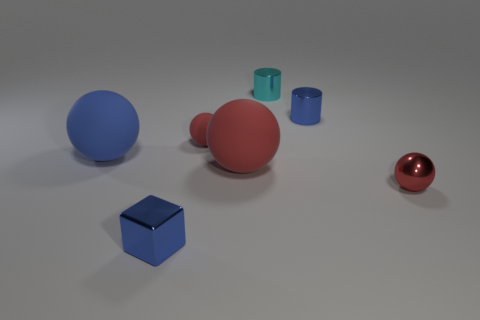There is a tiny ball that is on the right side of the big red rubber ball; is its color the same as the tiny rubber thing?
Offer a terse response. Yes. There is a blue matte object that is the same shape as the small red shiny thing; what size is it?
Offer a terse response. Large. What number of small spheres have the same material as the cube?
Ensure brevity in your answer.  1. There is a small blue thing behind the big object that is left of the small blue cube; is there a blue metallic thing on the left side of it?
Provide a short and direct response. Yes. What is the shape of the small rubber object?
Make the answer very short. Sphere. Is the tiny red sphere that is left of the tiny red shiny thing made of the same material as the blue thing on the right side of the small blue metallic block?
Keep it short and to the point. No. How many tiny shiny cylinders are the same color as the small block?
Provide a short and direct response. 1. There is a small metal thing that is in front of the tiny blue cylinder and left of the tiny red metal sphere; what is its shape?
Provide a short and direct response. Cube. There is a rubber thing that is both left of the large red rubber ball and on the right side of the large blue rubber thing; what color is it?
Your answer should be compact. Red. Are there more tiny blue objects to the left of the tiny cyan metal thing than blue rubber balls to the right of the tiny rubber object?
Your response must be concise. Yes. 